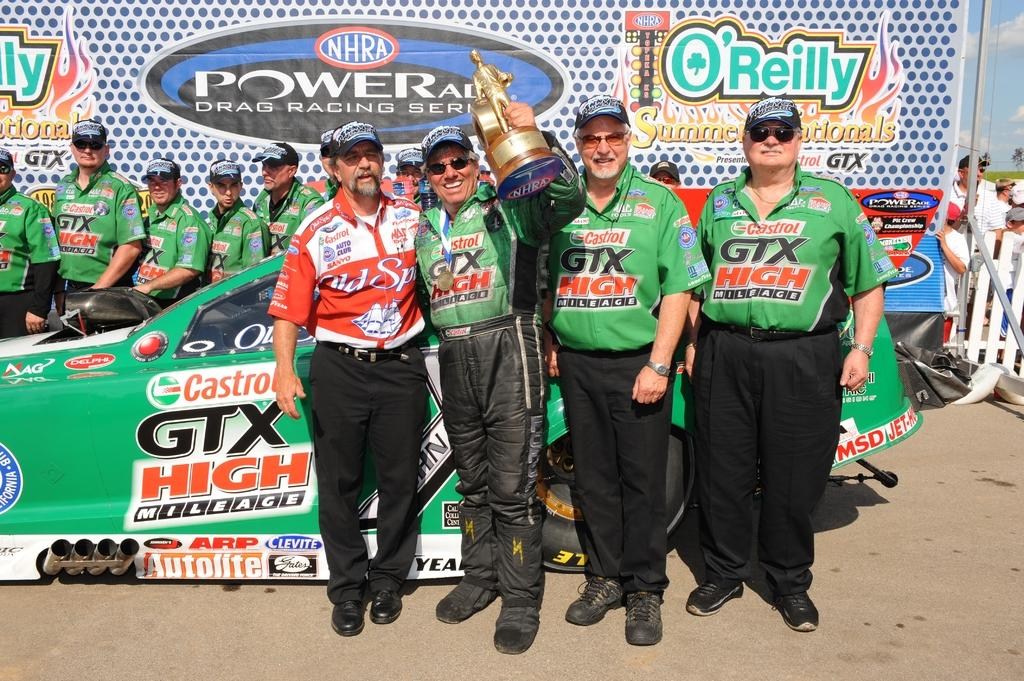<image>
Write a terse but informative summary of the picture. Members of an NHRA drag race team standing in front of a race car with one member holding up a trophy. 